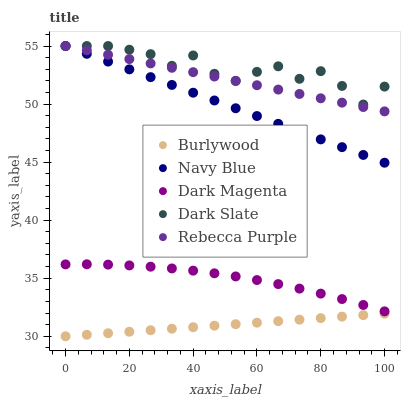Does Burlywood have the minimum area under the curve?
Answer yes or no. Yes. Does Dark Slate have the maximum area under the curve?
Answer yes or no. Yes. Does Navy Blue have the minimum area under the curve?
Answer yes or no. No. Does Navy Blue have the maximum area under the curve?
Answer yes or no. No. Is Burlywood the smoothest?
Answer yes or no. Yes. Is Dark Slate the roughest?
Answer yes or no. Yes. Is Navy Blue the smoothest?
Answer yes or no. No. Is Navy Blue the roughest?
Answer yes or no. No. Does Burlywood have the lowest value?
Answer yes or no. Yes. Does Navy Blue have the lowest value?
Answer yes or no. No. Does Dark Slate have the highest value?
Answer yes or no. Yes. Does Dark Magenta have the highest value?
Answer yes or no. No. Is Burlywood less than Rebecca Purple?
Answer yes or no. Yes. Is Rebecca Purple greater than Burlywood?
Answer yes or no. Yes. Does Rebecca Purple intersect Dark Slate?
Answer yes or no. Yes. Is Rebecca Purple less than Dark Slate?
Answer yes or no. No. Is Rebecca Purple greater than Dark Slate?
Answer yes or no. No. Does Burlywood intersect Rebecca Purple?
Answer yes or no. No. 